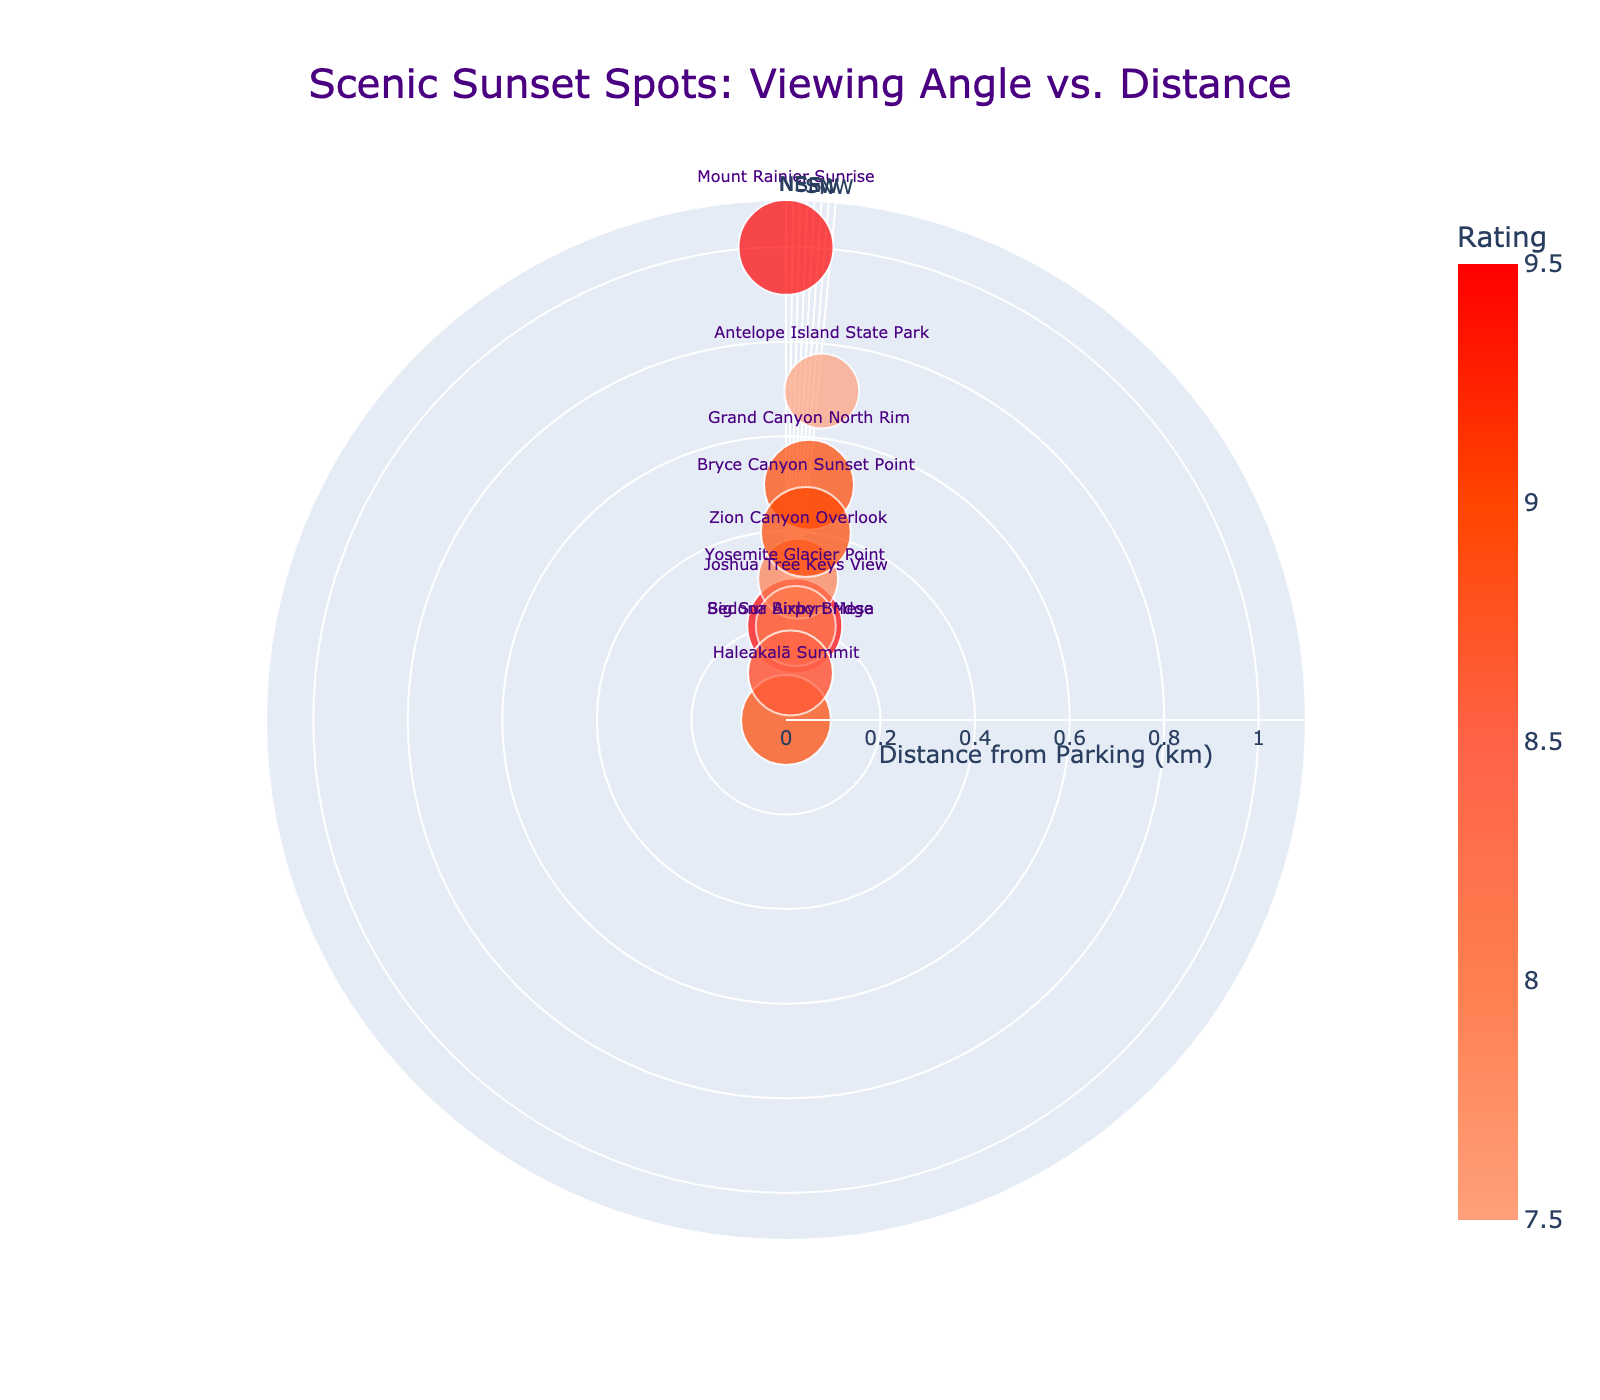What is the title of the chart? The title of the chart is usually displayed at the top of the figure. The information shows "Scenic Sunset Spots: Viewing Angle vs. Distance."
Answer: Scenic Sunset Spots: Viewing Angle vs. Distance How many spots have a rating of 9 or above? To find this, identify spots with ratings of 9 or above and count them. The spots are: Grand Canyon North Rim, Yosemite Glacier Point, Haleakalā Summit, Bryce Canyon Sunset Point, and Mount Rainier Sunrise, giving us five spots.
Answer: 5 Which scenic spot is the closest to the parking area? Look for the spot with the smallest distance from parking. Haleakalā Summit has a distance of 0 km, making it the closest.
Answer: Haleakalā Summit What is the distance range shown in the radial axis? The radial axis representing the distance from parking ranges from 0 to the maximum distance value plus a buffer. In this chart, the range goes up to 0.8 km.
Answer: 0 to 0.8 km Which spots are located directly north? Look for spots with a Sunset Viewing Angle at 0 degrees (or radians for polar charts). Mount Rainier Sunrise is at 0 degrees.
Answer: Mount Rainier Sunrise What is the average rating of all the spots? Sum the ratings and divide by the number of spots. Ratings are: 9, 9.5, 8.5, 9, 8, 7.5, 8, 9, 9.5, and 8.5. Sum is 86.5, divided by 10 spots gives an average rating of 8.65.
Answer: 8.65 Which spot offers a sunset view between E and SE direction? Check angular directions between 90 (East) and 135 (South-East). No spots are located within this angle range.
Answer: None Which spot has the same rating as Grand Canyon North Rim but a larger distance from parking? Grand Canyon North Rim has a rating of 9. Bryce Canyon Sunset Point also has a rating of 9 but is farther away at 0.4 km compared to 0.5 km.
Answer: Bryce Canyon Sunset Point Is there any spot with a sunset viewing angle within 10 degrees of north (0 degree)? Identify spots with angles between 350 and 10 degrees. Antelope Island State Park (355) and Mount Rainier Sunrise (0) fit this criterion.
Answer: Antelope Island State Park, Mount Rainier Sunrise 